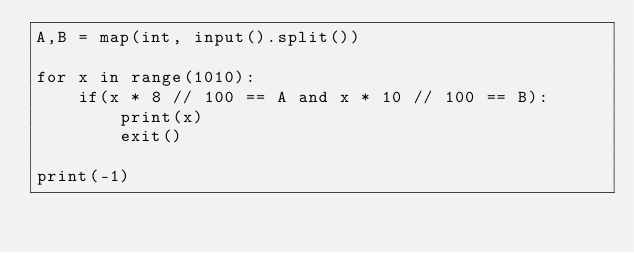Convert code to text. <code><loc_0><loc_0><loc_500><loc_500><_Python_>A,B = map(int, input().split())

for x in range(1010):
    if(x * 8 // 100 == A and x * 10 // 100 == B):
        print(x)
        exit()
    
print(-1)</code> 